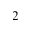<formula> <loc_0><loc_0><loc_500><loc_500>_ { 2 }</formula> 